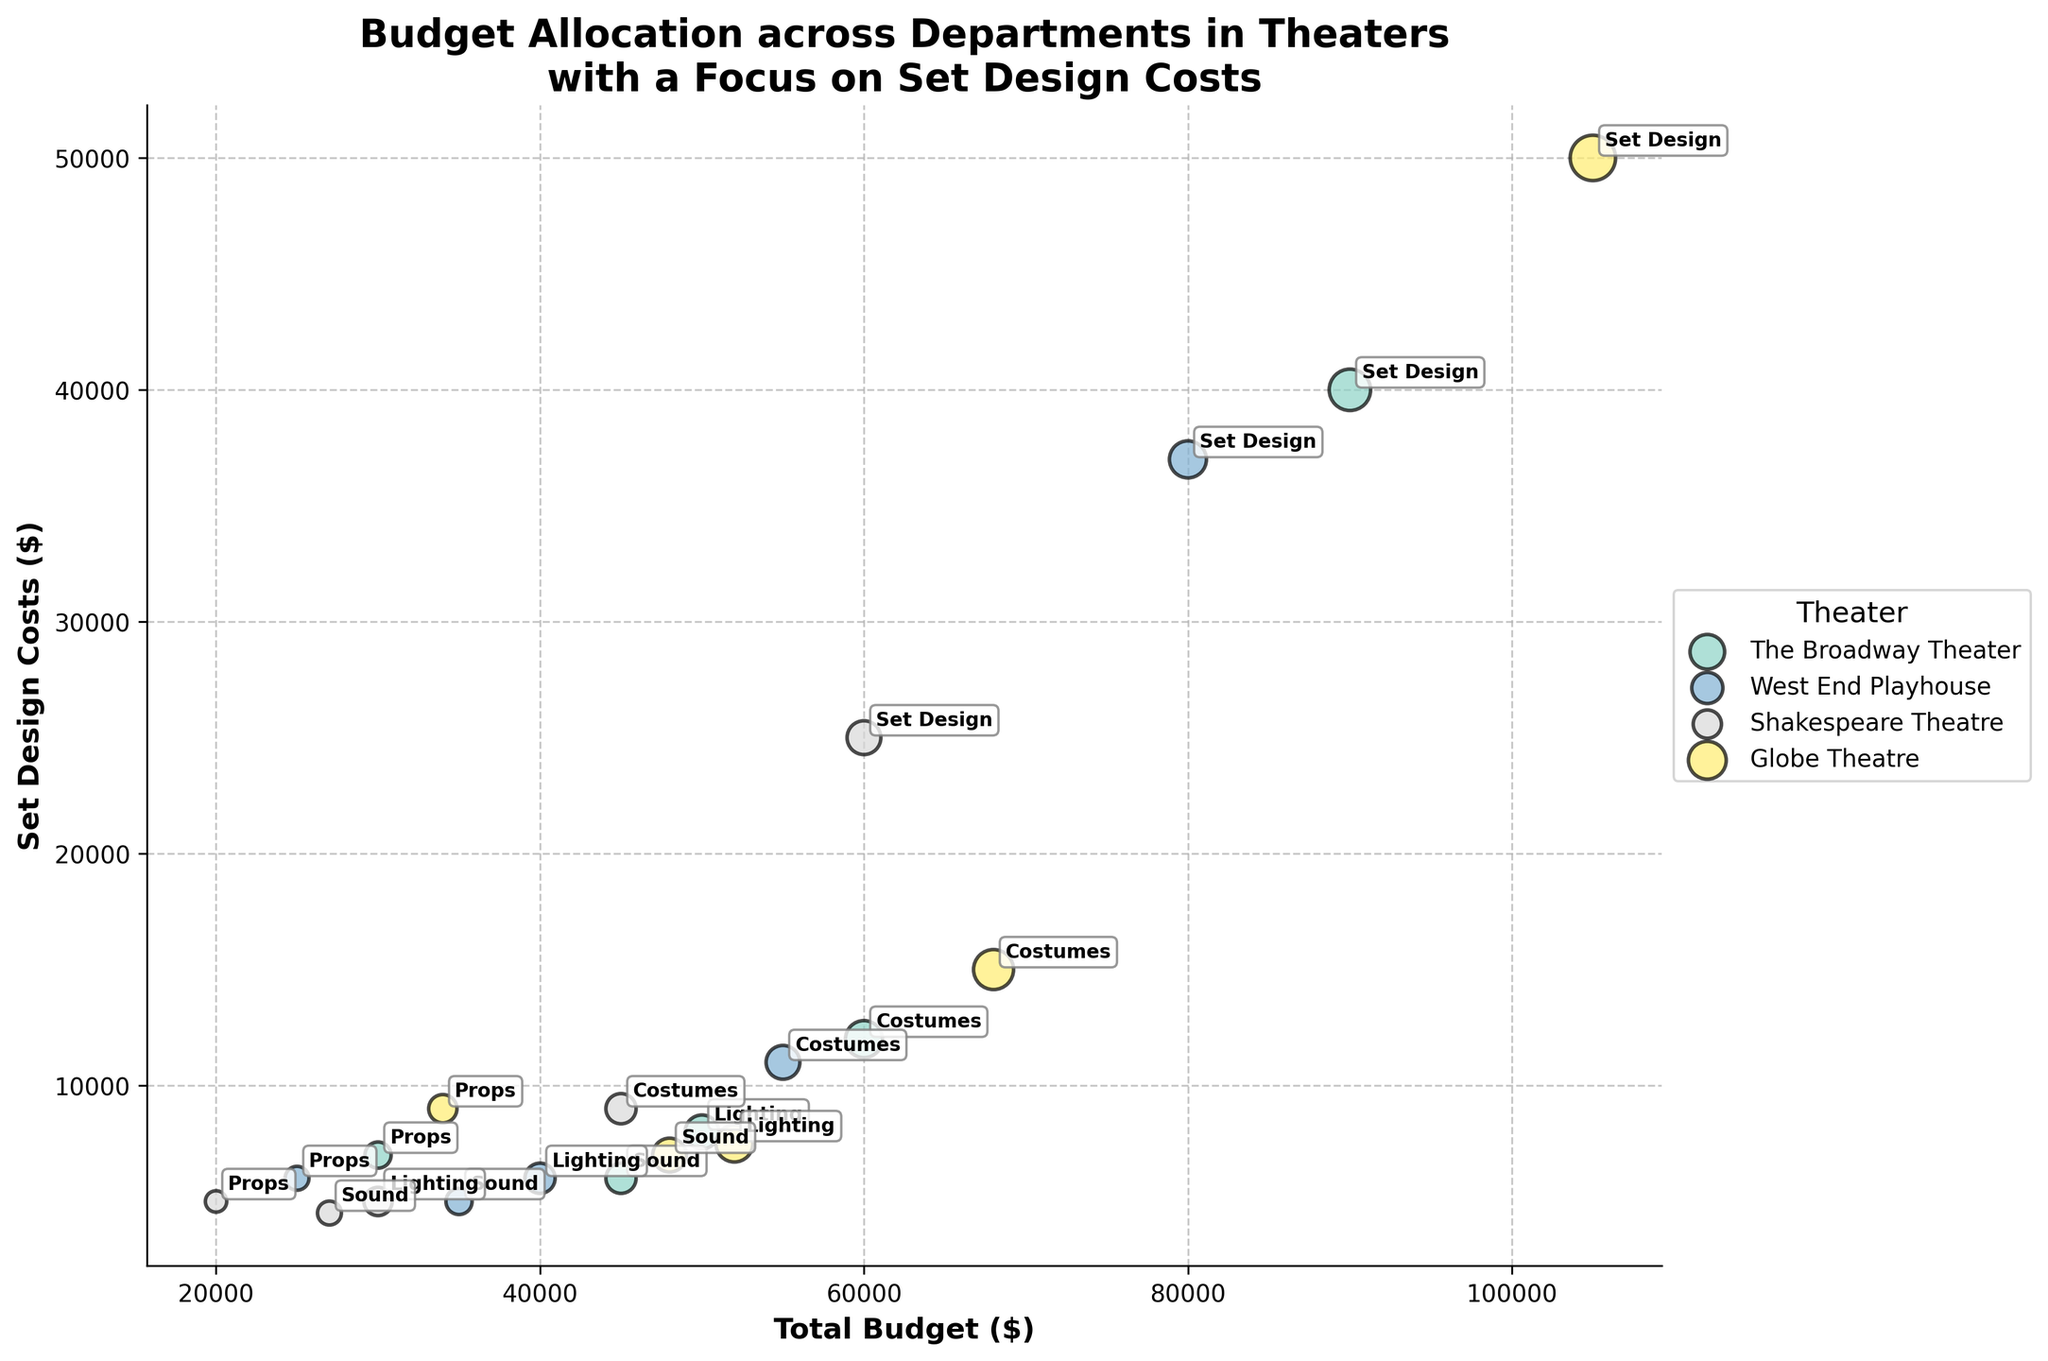What is the title of the plot? The title of the plot is displayed at the top of the figure. It reads "Budget Allocation across Departments in Theaters with a Focus on Set Design Costs".
Answer: Budget Allocation across Departments in Theaters with a Focus on Set Design Costs Which department has the highest set design cost at The Broadway Theater? At The Broadway Theater, the data for the 'Set Design' department shows the highest set design cost, which is represented by the highest y-coordinate value.
Answer: Set Design How many theaters are presented in the plot? The plot's legend shows different colors representing each theater, and by counting the distinct colors in the legend, we can determine the number of theaters. The legend indicates four theaters.
Answer: 4 What is the total budget for West End Playhouse? To find the total budget for West End Playhouse, sum up the x-coordinate values of all departments linked to it. These values are: 40000 + 35000 + 55000 + 80000 + 25000.
Answer: 235,000 Which theater has the set design department with the lowest cost? By looking at the y-coordinate values for the 'Set Design' departments across theaters, we locate the lowest position which corresponds to the Shakespeare Theatre.
Answer: Shakespeare Theatre Which theater has the largest bubble for set design costs? The size of the bubbles represents the employee count, scaled up in size. The largest bubble on the y-axis for 'Set Design' is found for the Globe Theatre.
Answer: Globe Theatre What is the average set design cost across all theaters? To find this, sum the set design costs for all theaters (40000 + 37000 + 25000 + 50000) and divide by the number of theaters (4).
Answer: $38,000 Which theater has the highest total budget for lighting? To identify this, compare the x-values for 'Lighting' across all theaters. The highest x-value for lighting is found for the Globe Theatre.
Answer: Globe Theatre What is the difference in set design costs between The Broadway Theater and West End Playhouse? Subtract the set design cost of West End Playhouse from The Broadway Theater (40000 - 37000).
Answer: $3,000 Which department at the Shakespeare Theatre has the smallest total budget? Look for the smallest x-coordinate value among the departments in the Shakespeare Theatre. The 'Props' department has the smallest total budget.
Answer: Props 